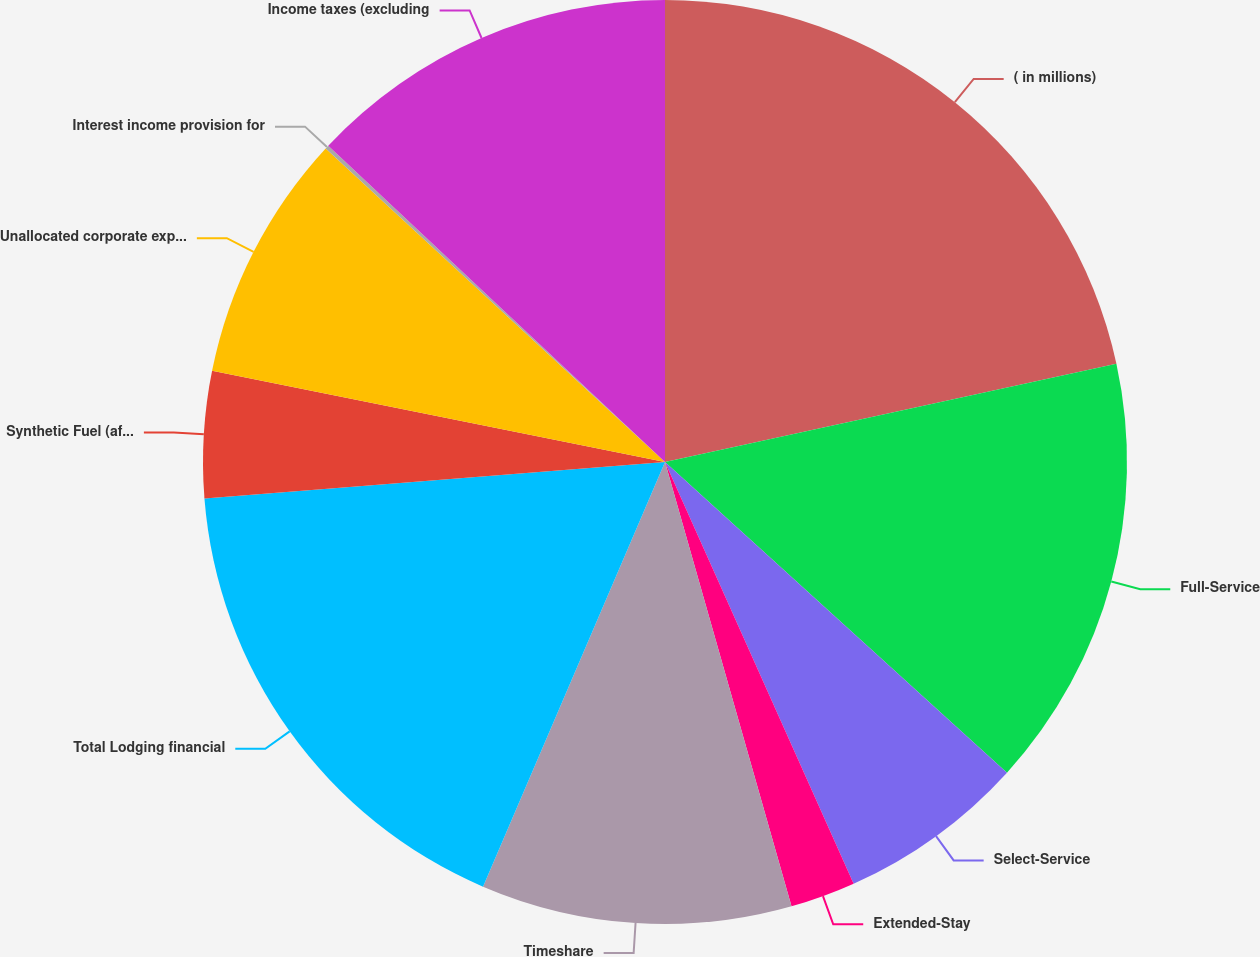<chart> <loc_0><loc_0><loc_500><loc_500><pie_chart><fcel>( in millions)<fcel>Full-Service<fcel>Select-Service<fcel>Extended-Stay<fcel>Timeshare<fcel>Total Lodging financial<fcel>Synthetic Fuel (after-tax)<fcel>Unallocated corporate expenses<fcel>Interest income provision for<fcel>Income taxes (excluding<nl><fcel>21.59%<fcel>15.15%<fcel>6.57%<fcel>2.28%<fcel>10.86%<fcel>17.3%<fcel>4.42%<fcel>8.71%<fcel>0.13%<fcel>13.0%<nl></chart> 